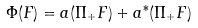<formula> <loc_0><loc_0><loc_500><loc_500>\Phi ( F ) = a ( \Pi _ { + } F ) + a ^ { * } ( \Pi _ { + } F )</formula> 